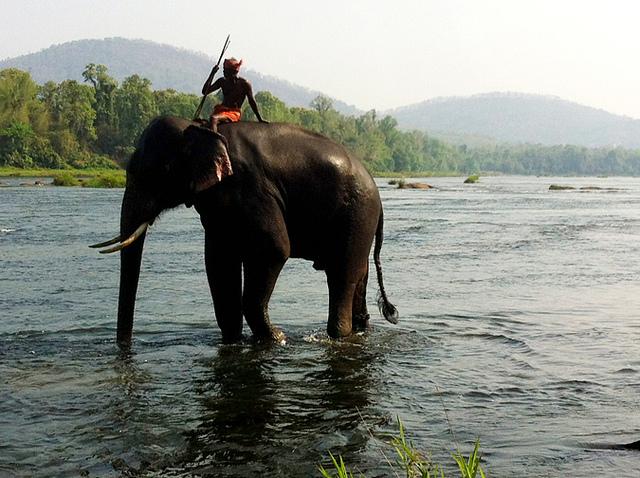Is there a man riding the elephant?
Give a very brief answer. Yes. How many tusks do you see?
Write a very short answer. 2. What is the general direction of the current?
Give a very brief answer. Left. 